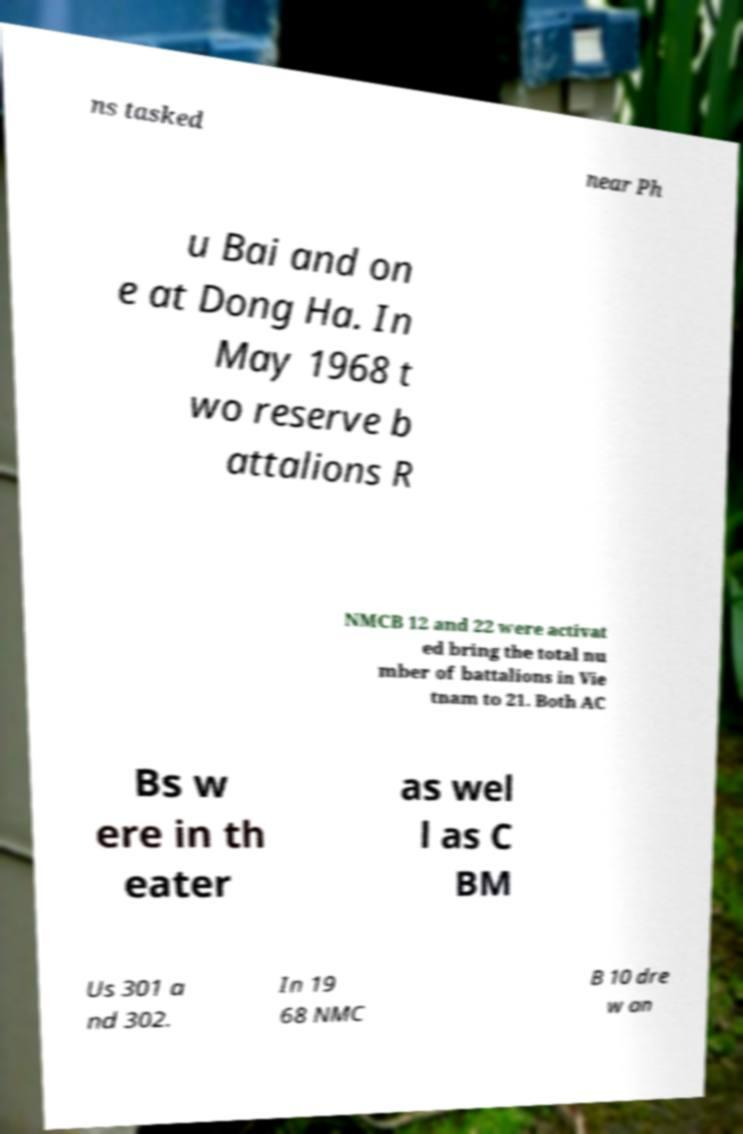There's text embedded in this image that I need extracted. Can you transcribe it verbatim? ns tasked near Ph u Bai and on e at Dong Ha. In May 1968 t wo reserve b attalions R NMCB 12 and 22 were activat ed bring the total nu mber of battalions in Vie tnam to 21. Both AC Bs w ere in th eater as wel l as C BM Us 301 a nd 302. In 19 68 NMC B 10 dre w an 